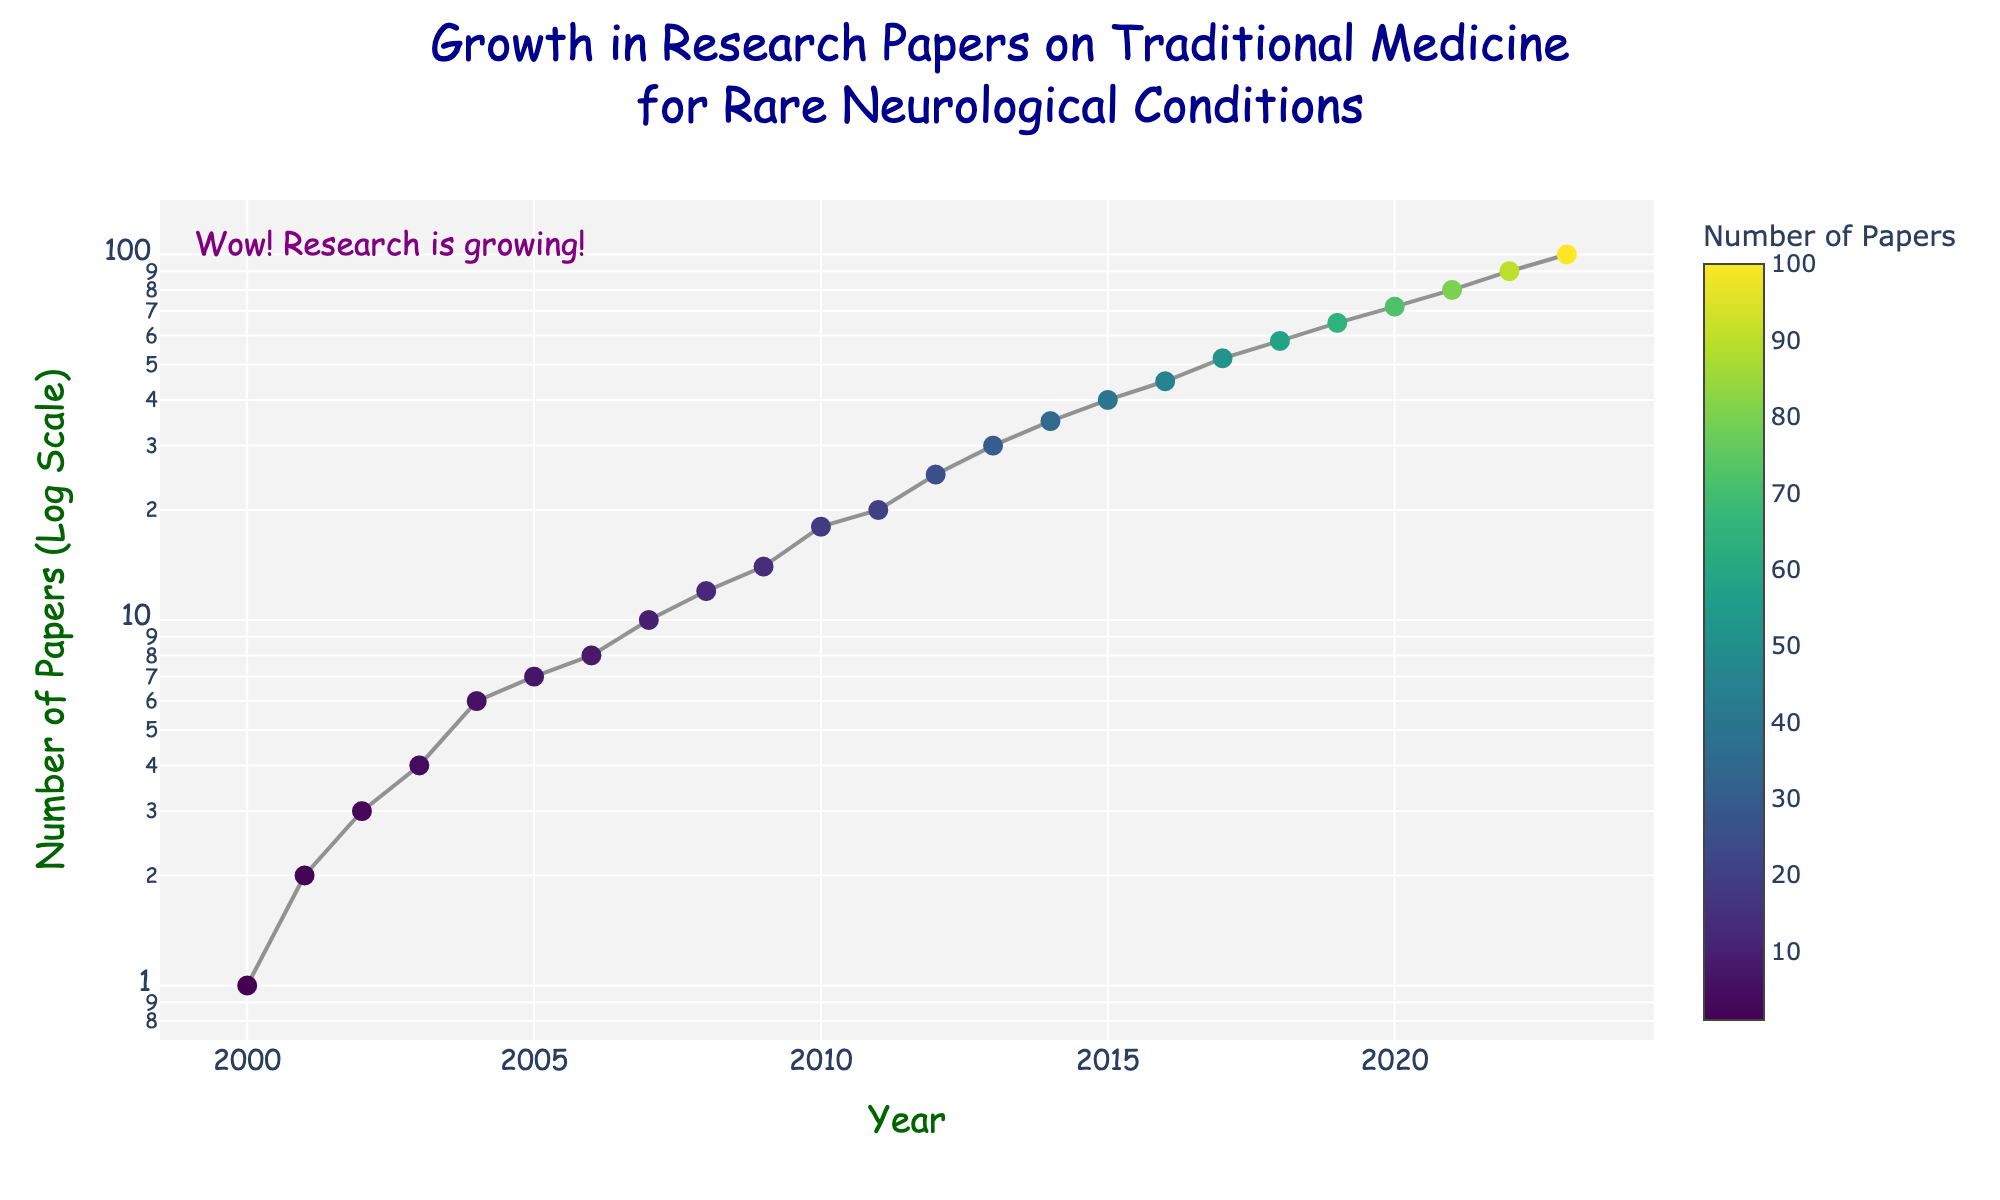what is the title of the plot? The title is located at the top center of the plot, displaying the overall subject of the scatter plot. It tells us the main focus, which in this case relates to the trends in research papers over time. By reading the text at the top, one can identify that the title is "Growth in Research Papers on Traditional Medicine for Rare Neurological Conditions."
Answer: Growth in Research Papers on Traditional Medicine for Rare Neurological Conditions How many data points are there in the plot? Count the number of distinct markers present in the scatter plot. These markers represent the yearly data points from 2000 to 2023. Each year has a corresponding value for the number of papers published. By counting these markers, we can determine there are 24 data points.
Answer: 24 What is the year with the highest number of published papers? Observe the x-axis to locate the year with the highest value on the y-axis in the scatter plot. The highest point on the graph corresponds to 2023, where the number of published papers peaks.
Answer: 2023 How much more did the number of papers increase between 2000 and 2023? Look at the y-axis values corresponding to the years 2000 and 2023. In 2000, the number of papers is 1, and in 2023 it is 100. Subtract the number in 2000 from the number in 2023 to determine the increase: 100 - 1.
Answer: 99 What is the approximate average number of papers published from 2000 to 2023? Sum the numbers of papers for all years from 2000 to 2023, then divide by the total number of years (24). (1 + 2 + 3 + 4 + 6 + 7 + 8 + 10 + 12 + 14 + 18 + 20 + 25 + 30 + 35 + 40 + 45 + 52 + 58 + 65 + 72 + 80 + 90 + 100) / 24 = 24.8333.
Answer: 24.83 How many years show fewer than 10 papers published? Examine the y-values from the year 2000 up to where the number of papers first surpasses 10. The years with fewer than 10 papers are: 2000 (1), 2001 (2), 2002 (3), 2003 (4), 2004 (6), 2005 (7), 2006 (8), 2007 (10). There are 8 years with fewer than 10 papers.
Answer: 8 In what year did the number of papers first reach double digits (10 or more)? Follow the y-axis upward from zero and track which year shows 10 or more papers for the first time. According to the data, the number first reached 10 papers in the year 2007.
Answer: 2007 Which period saw the largest increase in the number of papers published (in one year)? To determine the largest year-over-year increase, calculate the difference in the number of papers for each subsequent year. Identify the maximum difference from year to year. For example, the increase from 2022 (90 papers) to 2023 (100 papers) is 10, which is the largest increase.
Answer: 2022-2023 What is the trend in the number of papers published over time? By observing the overall direction of the scatter plot and the connecting line, we see that the number of papers steadily increases over the years. The markers form an upward trend, indicating that the number of research papers on traditional medicine for rare neurological conditions has been growing over time.
Answer: Increasing Why is the y-axis labeled with a log scale? The y-axis uses a log scale because the data spans a large range of values. A regular scale would not effectively show the differences in smaller values as the values grow larger over time. The log scale allows us to better visualize and compare both small and large numbers in the growth of published papers.
Answer: Allows visualization of large range of values 